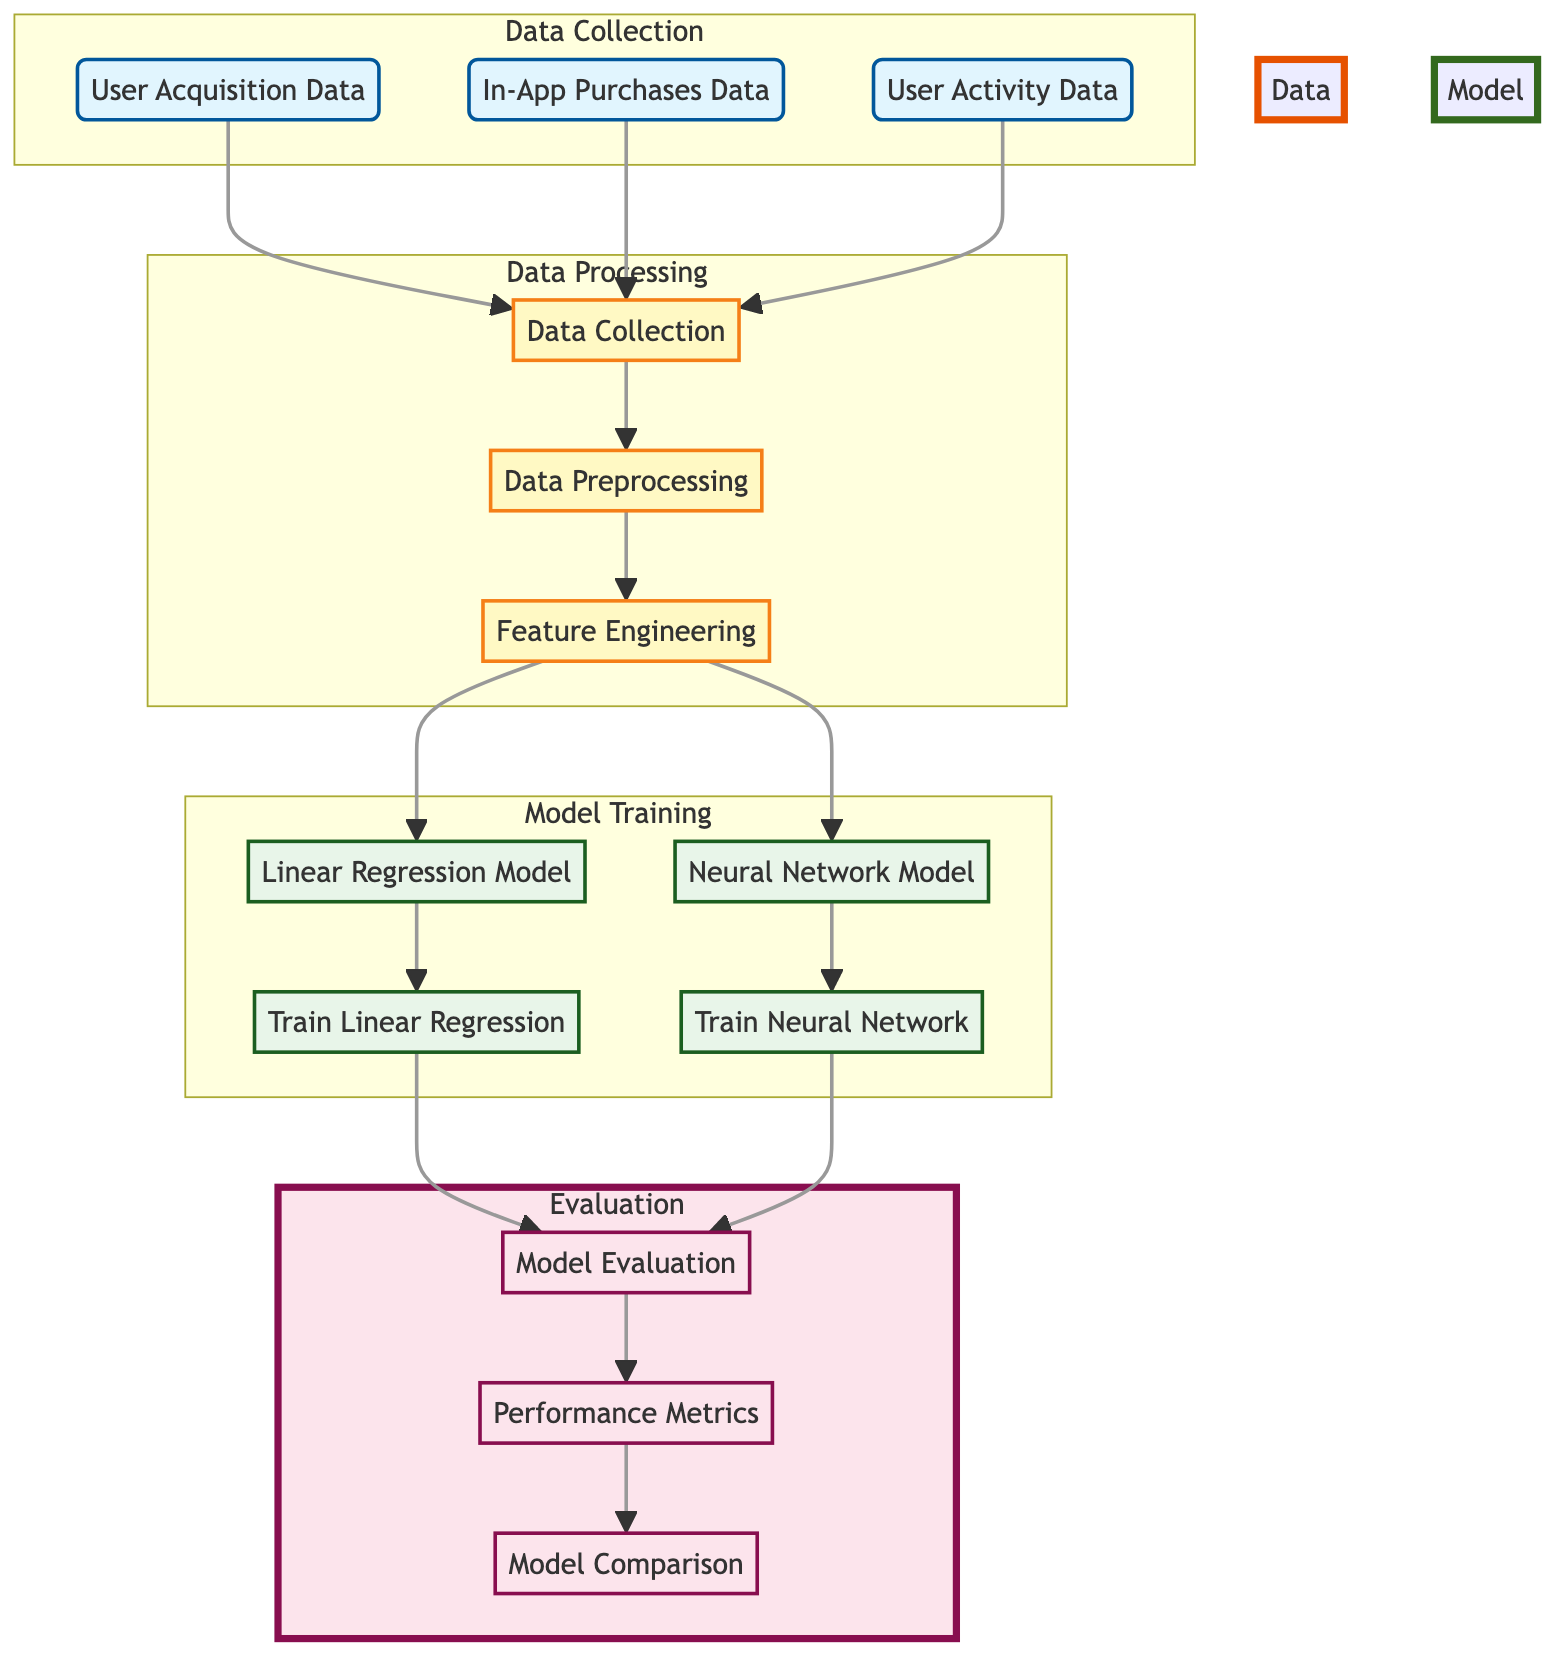What data is collected for the model training? The diagram shows three types of data collected for model training: User Acquisition Data, In-App Purchases Data, and User Activity Data. Each of these nodes connects directly to the Data Collection node.
Answer: User Acquisition Data, In-App Purchases Data, User Activity Data How many models are trained in the Model Training section? The Model Training section includes two models: the Linear Regression Model and the Neural Network Model. Therefore, there are a total of two models being trained.
Answer: 2 What are the performance metrics evaluated after model evaluation? The diagram indicates that after the Model Evaluation, the next step leads to Performance Metrics, which is a node that is linked to Model Comparison. Therefore, the focus is on evaluating the performance metrics after the models are trained.
Answer: Performance Metrics Which preprocessing step comes after Data Collection? According to the diagram, after the Data Collection step, the next step is Data Preprocessing. This is a clear directional flow represented in the diagram.
Answer: Data Preprocessing What is the final step in the evaluation process? The evaluation process culminates with the Model Comparison node. It receives input from Performance Metrics, indicating that performance data is compared here.
Answer: Model Comparison In which subgraph does Feature Engineering occur? Feature Engineering is part of the Data Processing subgraph. The diagram places it after Data Preprocessing and before the Model Training section.
Answer: Data Processing 